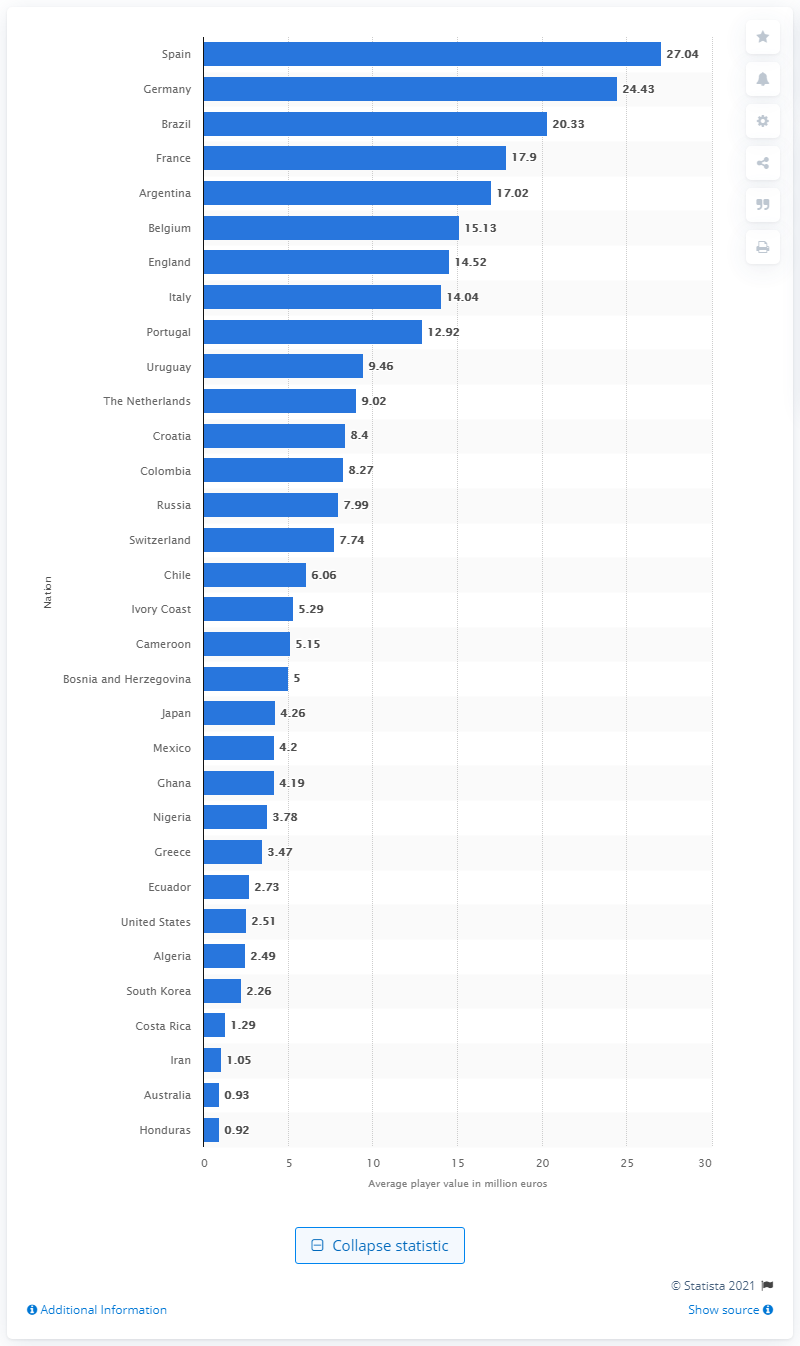Identify some key points in this picture. The 2014 FIFA World Cup was held in Brazil. The average market value of players on the Spanish national team is 27.04... 